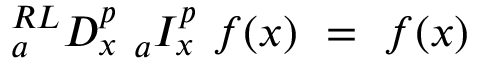<formula> <loc_0><loc_0><loc_500><loc_500>{ } _ { a } ^ { R L } D _ { x } ^ { p _ { a } I _ { x } ^ { p } f ( x ) = f ( x )</formula> 